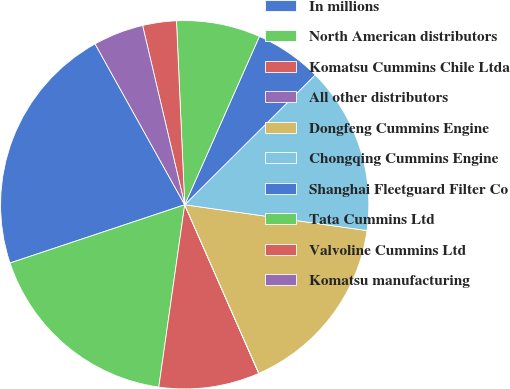Convert chart to OTSL. <chart><loc_0><loc_0><loc_500><loc_500><pie_chart><fcel>In millions<fcel>North American distributors<fcel>Komatsu Cummins Chile Ltda<fcel>All other distributors<fcel>Dongfeng Cummins Engine<fcel>Chongqing Cummins Engine<fcel>Shanghai Fleetguard Filter Co<fcel>Tata Cummins Ltd<fcel>Valvoline Cummins Ltd<fcel>Komatsu manufacturing<nl><fcel>22.03%<fcel>17.63%<fcel>8.83%<fcel>0.02%<fcel>16.16%<fcel>14.7%<fcel>5.89%<fcel>7.36%<fcel>2.96%<fcel>4.42%<nl></chart> 